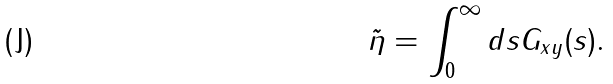Convert formula to latex. <formula><loc_0><loc_0><loc_500><loc_500>\tilde { \eta } = \int _ { 0 } ^ { \infty } d s G _ { x y } ( s ) .</formula> 